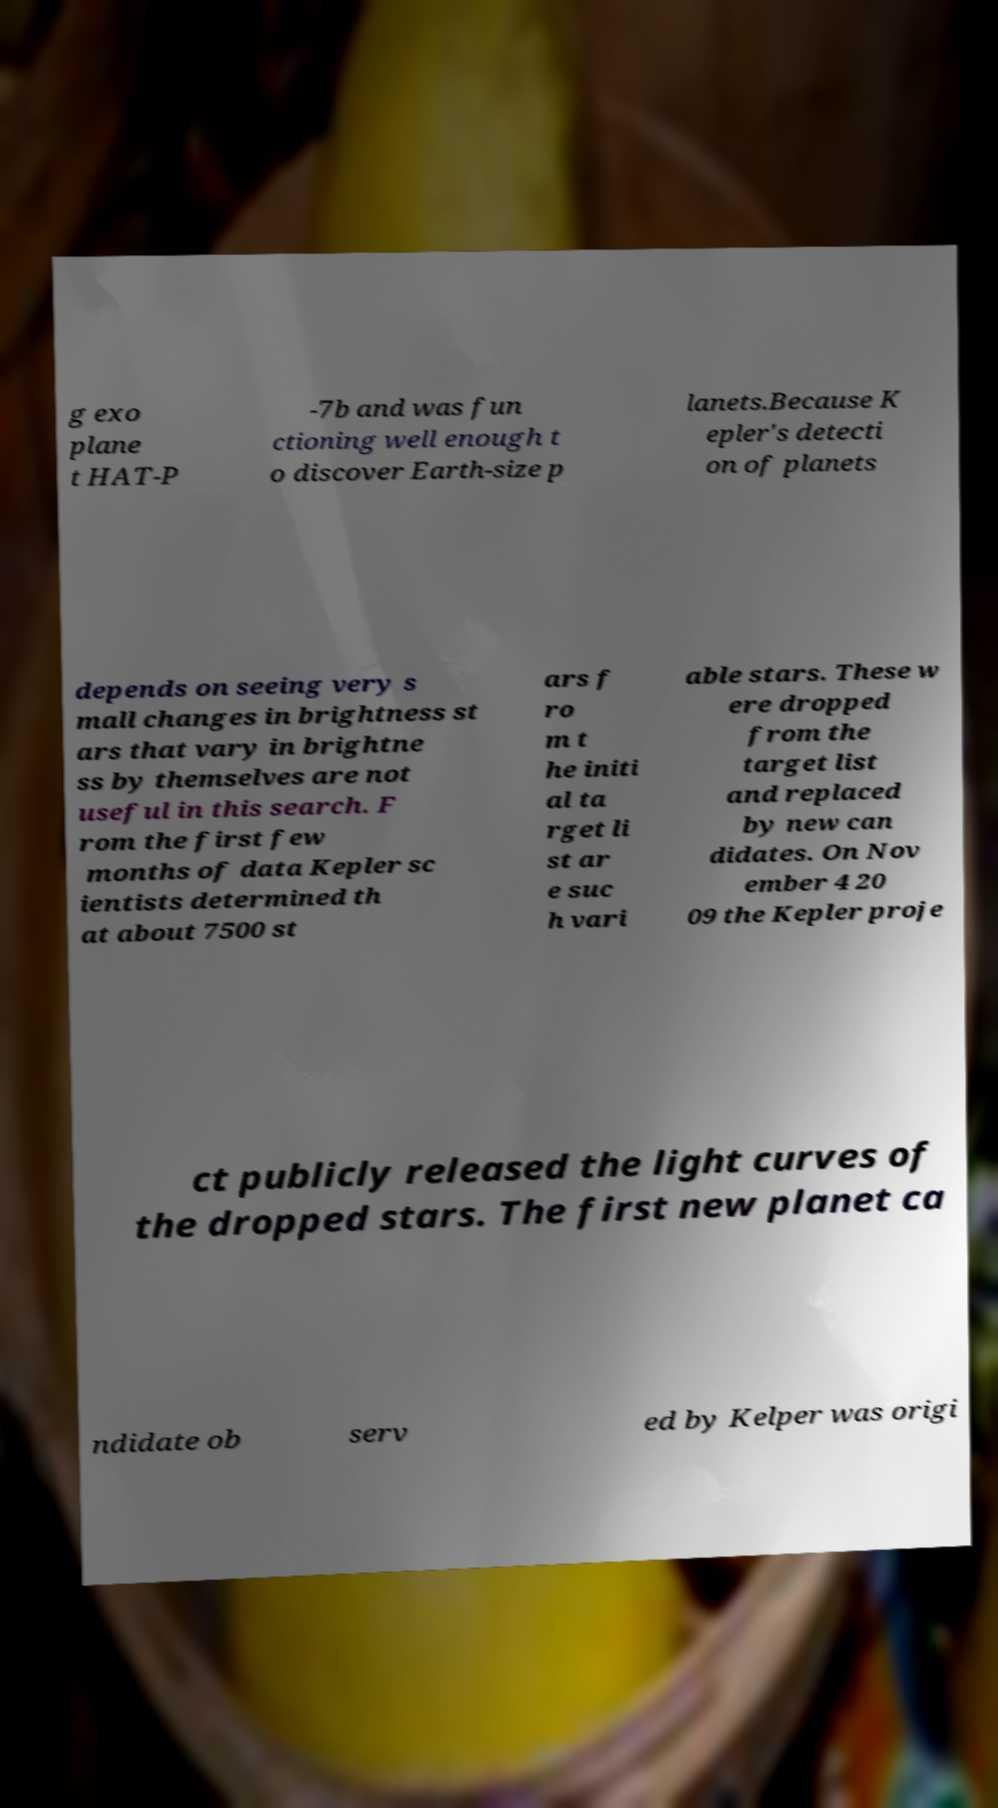Please read and relay the text visible in this image. What does it say? g exo plane t HAT-P -7b and was fun ctioning well enough t o discover Earth-size p lanets.Because K epler's detecti on of planets depends on seeing very s mall changes in brightness st ars that vary in brightne ss by themselves are not useful in this search. F rom the first few months of data Kepler sc ientists determined th at about 7500 st ars f ro m t he initi al ta rget li st ar e suc h vari able stars. These w ere dropped from the target list and replaced by new can didates. On Nov ember 4 20 09 the Kepler proje ct publicly released the light curves of the dropped stars. The first new planet ca ndidate ob serv ed by Kelper was origi 